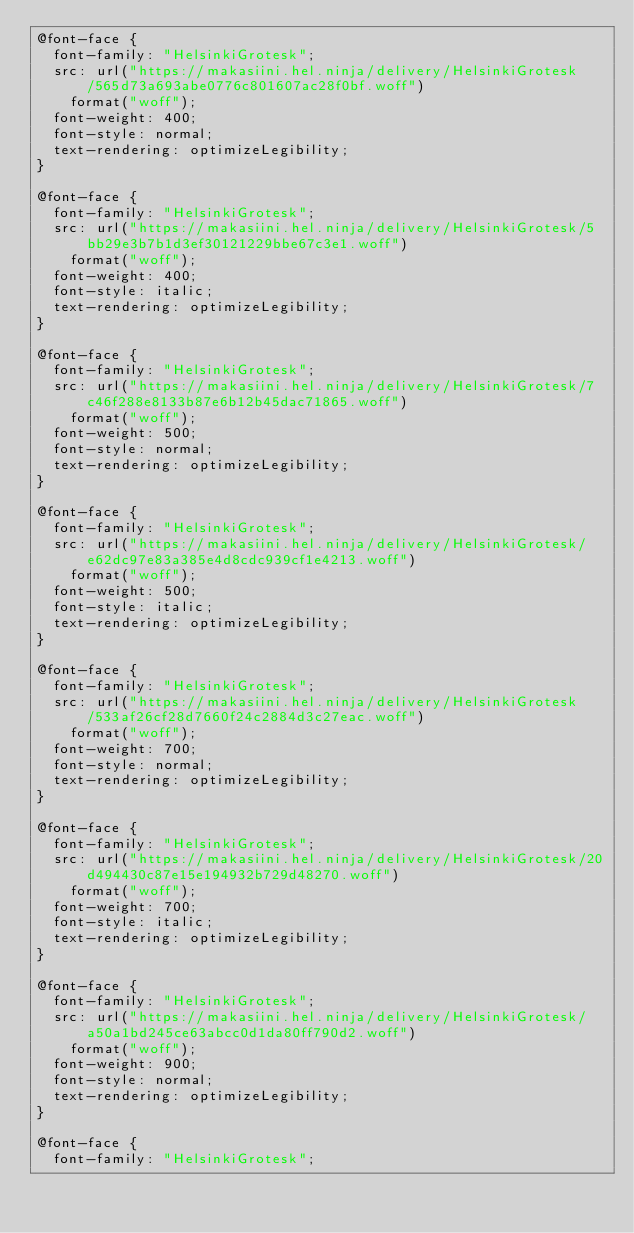Convert code to text. <code><loc_0><loc_0><loc_500><loc_500><_CSS_>@font-face {
  font-family: "HelsinkiGrotesk";
  src: url("https://makasiini.hel.ninja/delivery/HelsinkiGrotesk/565d73a693abe0776c801607ac28f0bf.woff")
    format("woff");
  font-weight: 400;
  font-style: normal;
  text-rendering: optimizeLegibility;
}

@font-face {
  font-family: "HelsinkiGrotesk";
  src: url("https://makasiini.hel.ninja/delivery/HelsinkiGrotesk/5bb29e3b7b1d3ef30121229bbe67c3e1.woff")
    format("woff");
  font-weight: 400;
  font-style: italic;
  text-rendering: optimizeLegibility;
}

@font-face {
  font-family: "HelsinkiGrotesk";
  src: url("https://makasiini.hel.ninja/delivery/HelsinkiGrotesk/7c46f288e8133b87e6b12b45dac71865.woff")
    format("woff");
  font-weight: 500;
  font-style: normal;
  text-rendering: optimizeLegibility;
}

@font-face {
  font-family: "HelsinkiGrotesk";
  src: url("https://makasiini.hel.ninja/delivery/HelsinkiGrotesk/e62dc97e83a385e4d8cdc939cf1e4213.woff")
    format("woff");
  font-weight: 500;
  font-style: italic;
  text-rendering: optimizeLegibility;
}

@font-face {
  font-family: "HelsinkiGrotesk";
  src: url("https://makasiini.hel.ninja/delivery/HelsinkiGrotesk/533af26cf28d7660f24c2884d3c27eac.woff")
    format("woff");
  font-weight: 700;
  font-style: normal;
  text-rendering: optimizeLegibility;
}

@font-face {
  font-family: "HelsinkiGrotesk";
  src: url("https://makasiini.hel.ninja/delivery/HelsinkiGrotesk/20d494430c87e15e194932b729d48270.woff")
    format("woff");
  font-weight: 700;
  font-style: italic;
  text-rendering: optimizeLegibility;
}

@font-face {
  font-family: "HelsinkiGrotesk";
  src: url("https://makasiini.hel.ninja/delivery/HelsinkiGrotesk/a50a1bd245ce63abcc0d1da80ff790d2.woff")
    format("woff");
  font-weight: 900;
  font-style: normal;
  text-rendering: optimizeLegibility;
}

@font-face {
  font-family: "HelsinkiGrotesk";</code> 